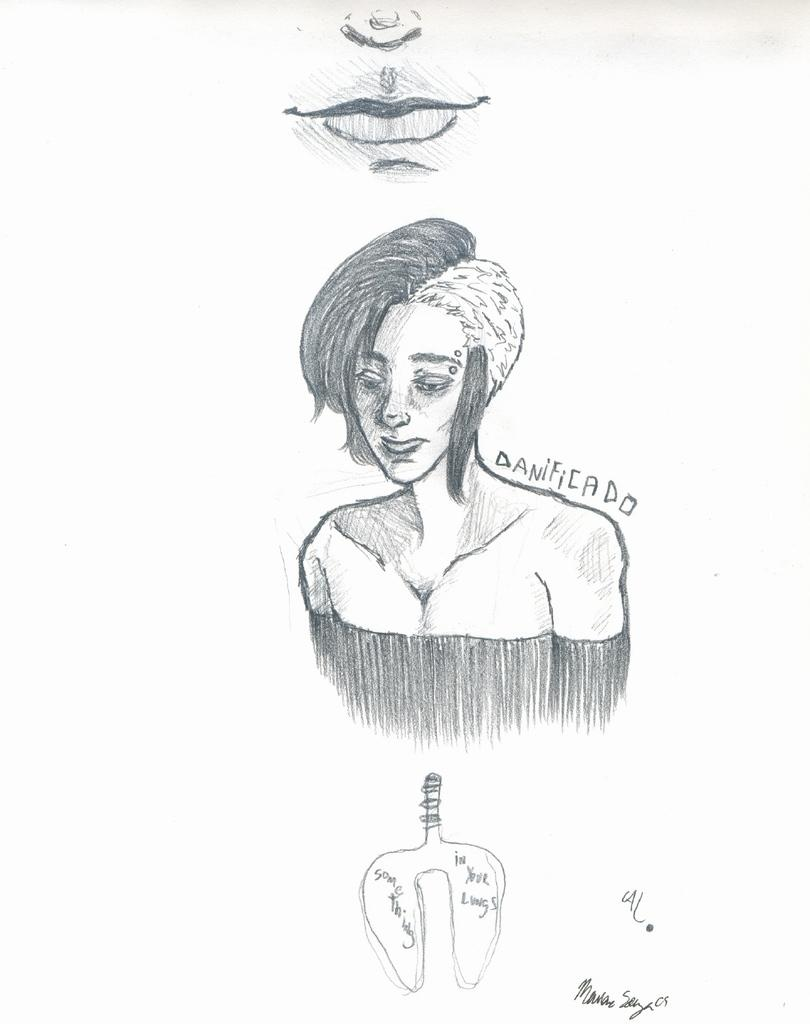What is the main subject of the image? The image contains an art piece. What does the art piece depict? The art piece depicts a woman. What is the woman thinking about in the image? The image does not provide any information about the woman's thoughts, so it cannot be determined from the image. 